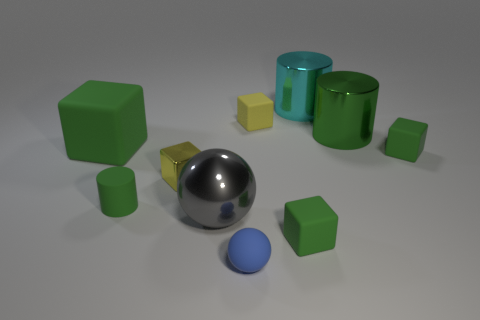Subtract all small green rubber blocks. How many blocks are left? 3 Subtract all cylinders. How many objects are left? 7 Subtract all green cubes. How many cubes are left? 2 Subtract 2 cylinders. How many cylinders are left? 1 Add 1 small metal cylinders. How many small metal cylinders exist? 1 Subtract 0 yellow cylinders. How many objects are left? 10 Subtract all blue cylinders. Subtract all gray cubes. How many cylinders are left? 3 Subtract all blue cylinders. How many yellow spheres are left? 0 Subtract all small cylinders. Subtract all big purple matte blocks. How many objects are left? 9 Add 7 balls. How many balls are left? 9 